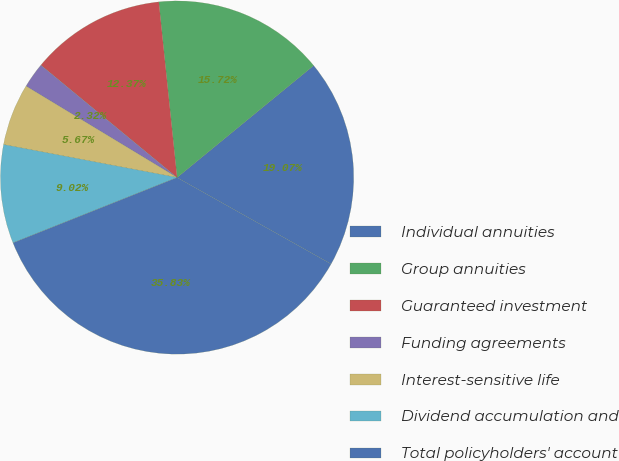<chart> <loc_0><loc_0><loc_500><loc_500><pie_chart><fcel>Individual annuities<fcel>Group annuities<fcel>Guaranteed investment<fcel>Funding agreements<fcel>Interest-sensitive life<fcel>Dividend accumulation and<fcel>Total policyholders' account<nl><fcel>19.07%<fcel>15.72%<fcel>12.37%<fcel>2.32%<fcel>5.67%<fcel>9.02%<fcel>35.83%<nl></chart> 